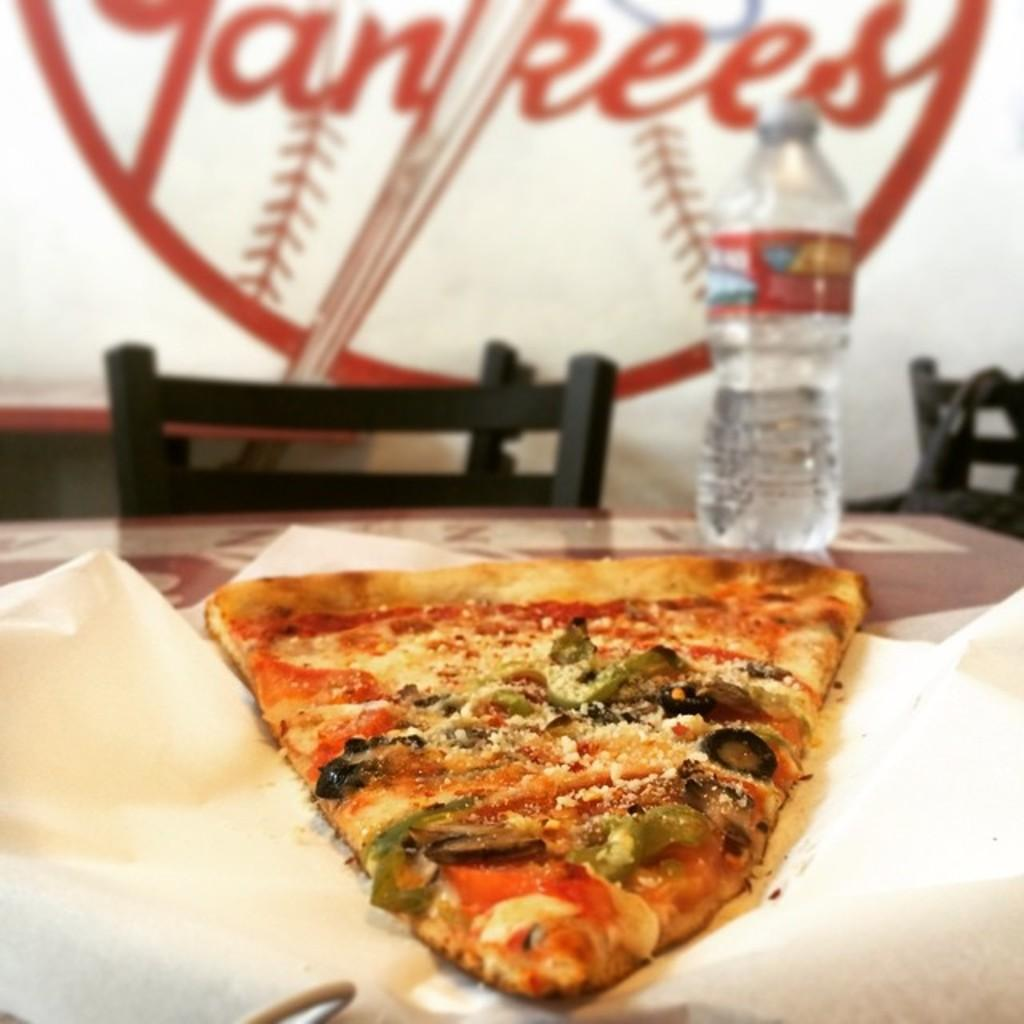What type of food is visible in the image? There is a piece of pizza in the image. What can be seen on the table in the image? There is a water bottle on the table in the image. What color is the chair in the image? The chair in the image is black. What type of clam is sitting on the pizza in the image? There are no clams present on the pizza in the image. What type of corn can be seen growing in the image? There is no corn visible in the image. 